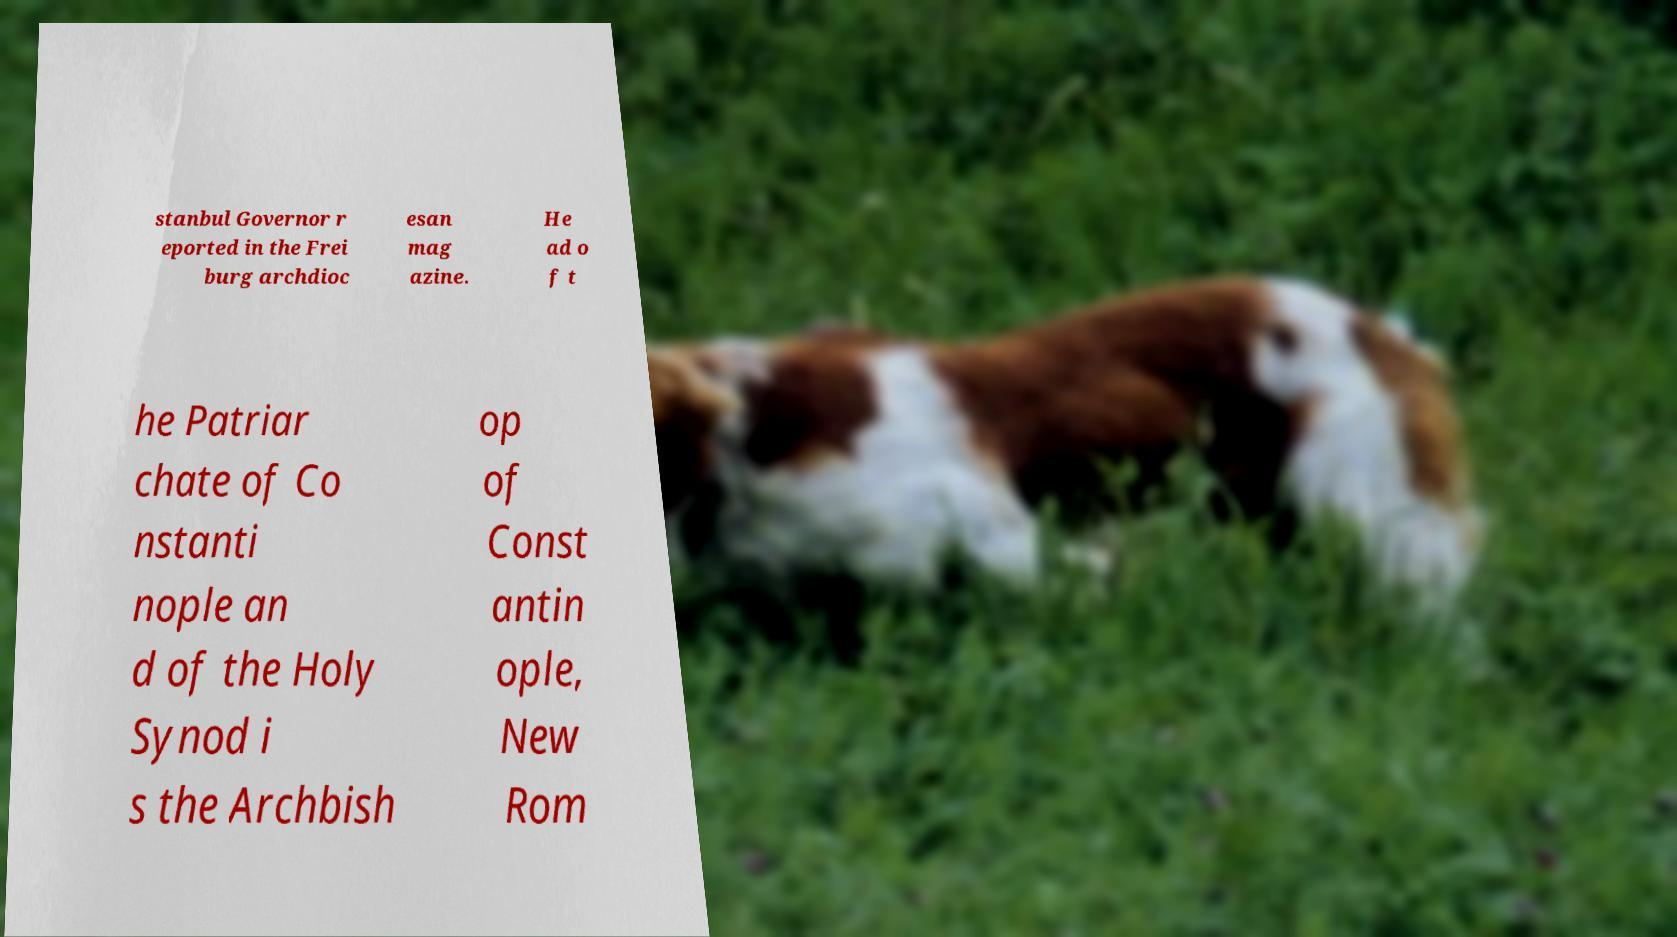Can you read and provide the text displayed in the image?This photo seems to have some interesting text. Can you extract and type it out for me? stanbul Governor r eported in the Frei burg archdioc esan mag azine. He ad o f t he Patriar chate of Co nstanti nople an d of the Holy Synod i s the Archbish op of Const antin ople, New Rom 